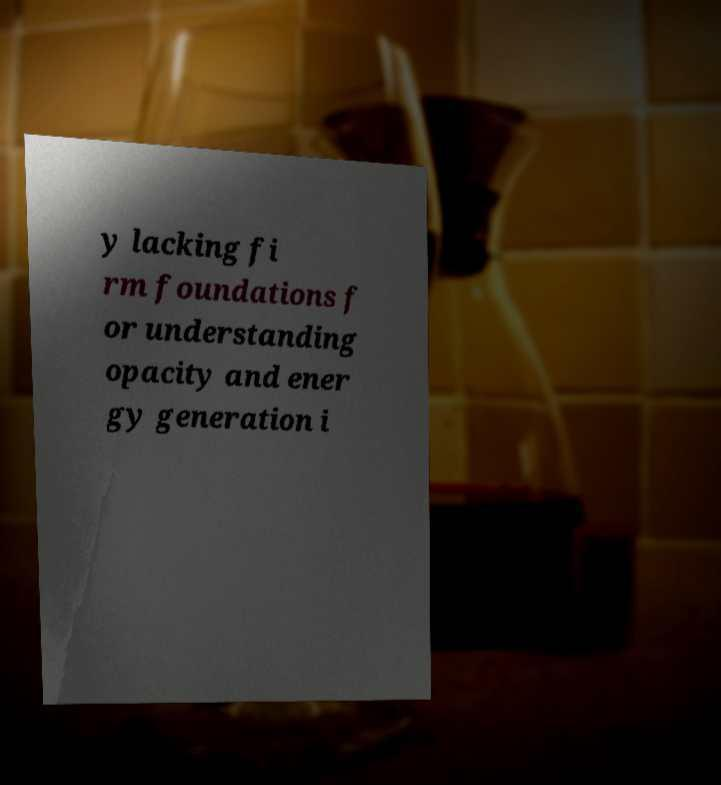Can you read and provide the text displayed in the image?This photo seems to have some interesting text. Can you extract and type it out for me? y lacking fi rm foundations f or understanding opacity and ener gy generation i 